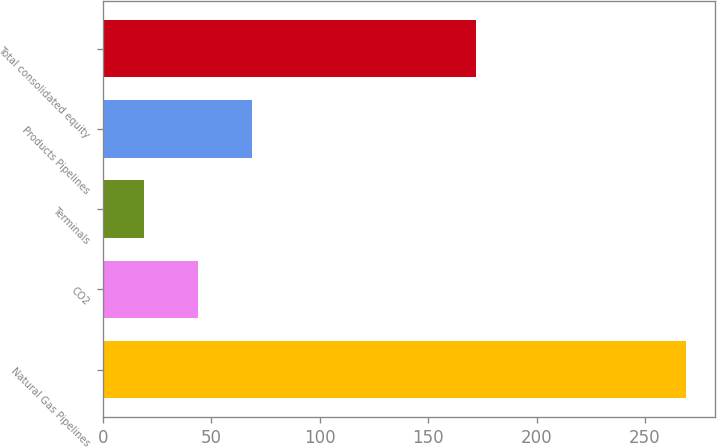<chart> <loc_0><loc_0><loc_500><loc_500><bar_chart><fcel>Natural Gas Pipelines<fcel>CO2<fcel>Terminals<fcel>Products Pipelines<fcel>Total consolidated equity<nl><fcel>269<fcel>44<fcel>19<fcel>69<fcel>172<nl></chart> 